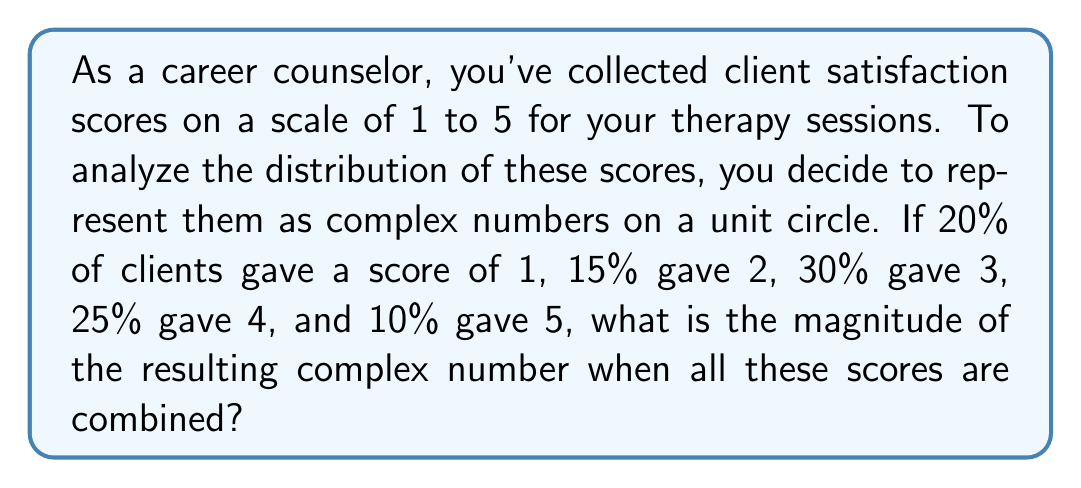Can you answer this question? Let's approach this step-by-step:

1) First, we need to represent each score as a complex number on the unit circle. We can do this by using the formula:

   $e^{i\theta} = \cos\theta + i\sin\theta$

   Where $\theta = \frac{2\pi(n-1)}{5}$ for scores n = 1, 2, 3, 4, 5

2) For each score:
   Score 1: $\theta = 0$, $z_1 = 1 + 0i$
   Score 2: $\theta = \frac{2\pi}{5}$, $z_2 = \cos\frac{2\pi}{5} + i\sin\frac{2\pi}{5}$
   Score 3: $\theta = \frac{4\pi}{5}$, $z_3 = \cos\frac{4\pi}{5} + i\sin\frac{4\pi}{5}$
   Score 4: $\theta = \frac{6\pi}{5}$, $z_4 = \cos\frac{6\pi}{5} + i\sin\frac{6\pi}{5}$
   Score 5: $\theta = \frac{8\pi}{5}$, $z_5 = \cos\frac{8\pi}{5} + i\sin\frac{8\pi}{5}$

3) Now, we need to weight each complex number by its percentage and sum:

   $Z = 0.20z_1 + 0.15z_2 + 0.30z_3 + 0.25z_4 + 0.10z_5$

4) Substituting the complex numbers:

   $Z = 0.20(1) + 0.15(\cos\frac{2\pi}{5} + i\sin\frac{2\pi}{5}) + 0.30(\cos\frac{4\pi}{5} + i\sin\frac{4\pi}{5}) + 0.25(\cos\frac{6\pi}{5} + i\sin\frac{6\pi}{5}) + 0.10(\cos\frac{8\pi}{5} + i\sin\frac{8\pi}{5})$

5) The magnitude of this complex number is given by $|Z| = \sqrt{a^2 + b^2}$, where $a$ is the real part and $b$ is the imaginary part.

6) Calculating $a$ and $b$:
   $a = 0.20 + 0.15\cos\frac{2\pi}{5} + 0.30\cos\frac{4\pi}{5} + 0.25\cos\frac{6\pi}{5} + 0.10\cos\frac{8\pi}{5} \approx 0.0878$
   $b = 0.15\sin\frac{2\pi}{5} + 0.30\sin\frac{4\pi}{5} + 0.25\sin\frac{6\pi}{5} + 0.10\sin\frac{8\pi}{5} \approx -0.2863$

7) Therefore, $|Z| = \sqrt{0.0878^2 + (-0.2863)^2} \approx 0.2992$
Answer: $|Z| \approx 0.2992$ 